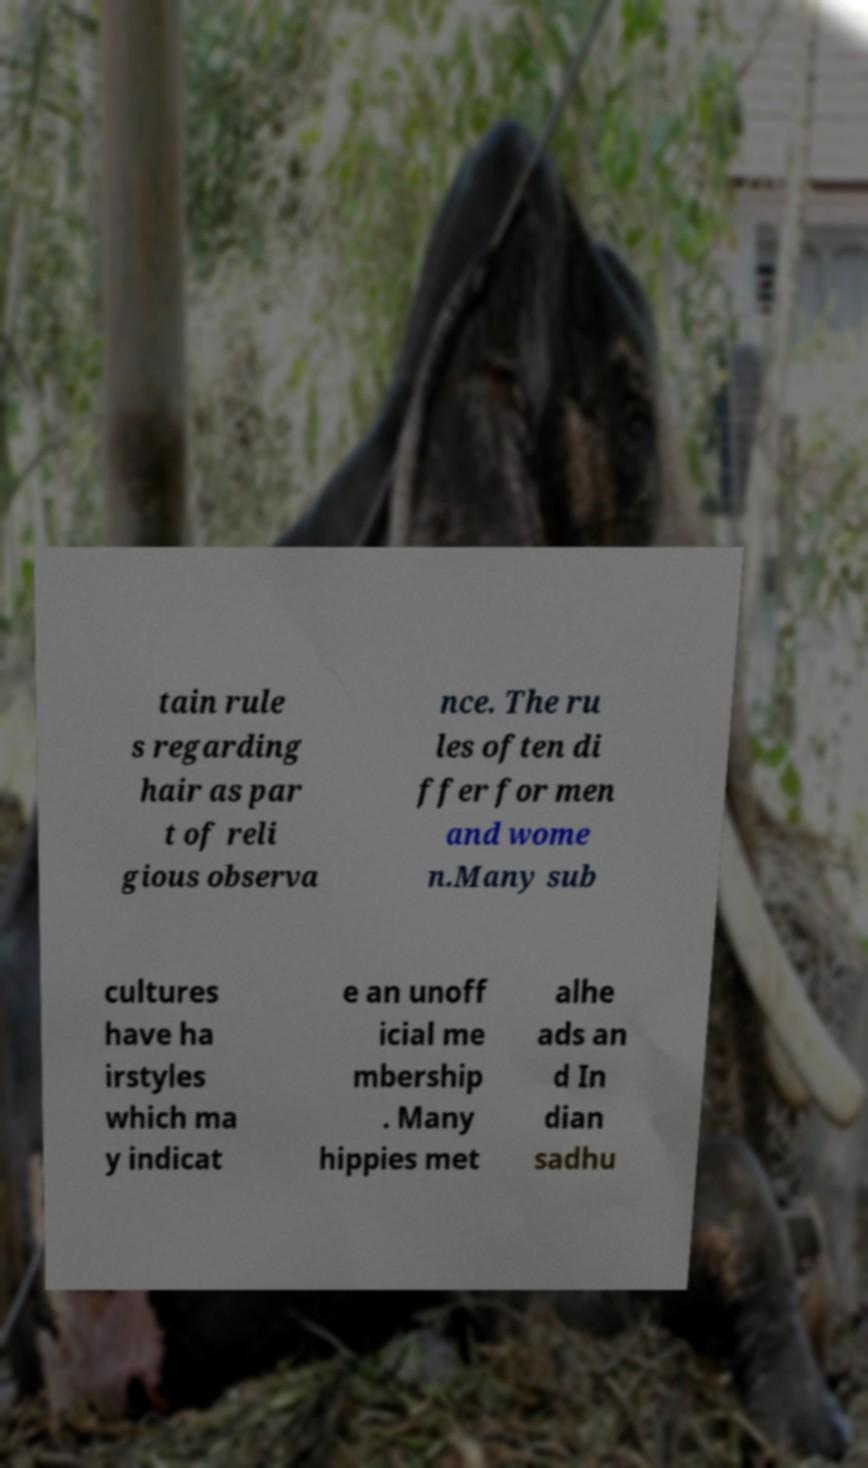For documentation purposes, I need the text within this image transcribed. Could you provide that? tain rule s regarding hair as par t of reli gious observa nce. The ru les often di ffer for men and wome n.Many sub cultures have ha irstyles which ma y indicat e an unoff icial me mbership . Many hippies met alhe ads an d In dian sadhu 